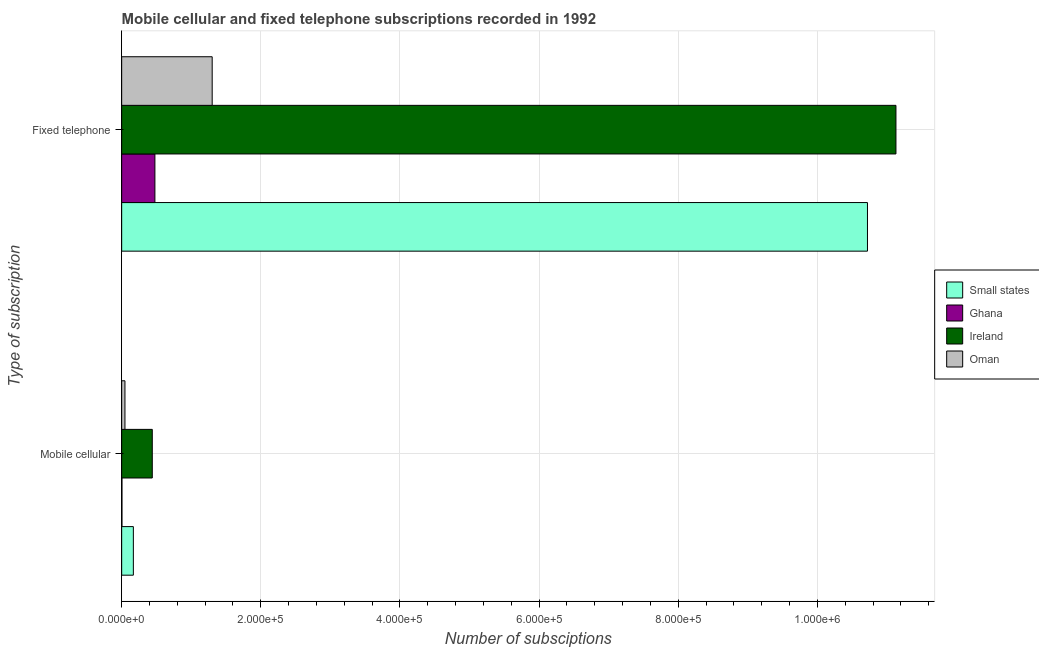Are the number of bars on each tick of the Y-axis equal?
Offer a terse response. Yes. What is the label of the 2nd group of bars from the top?
Your response must be concise. Mobile cellular. What is the number of mobile cellular subscriptions in Small states?
Make the answer very short. 1.68e+04. Across all countries, what is the maximum number of fixed telephone subscriptions?
Ensure brevity in your answer.  1.11e+06. Across all countries, what is the minimum number of mobile cellular subscriptions?
Your answer should be very brief. 400. In which country was the number of fixed telephone subscriptions maximum?
Keep it short and to the point. Ireland. In which country was the number of mobile cellular subscriptions minimum?
Make the answer very short. Ghana. What is the total number of fixed telephone subscriptions in the graph?
Provide a succinct answer. 2.36e+06. What is the difference between the number of fixed telephone subscriptions in Ireland and that in Ghana?
Make the answer very short. 1.07e+06. What is the difference between the number of mobile cellular subscriptions in Oman and the number of fixed telephone subscriptions in Small states?
Offer a terse response. -1.07e+06. What is the average number of mobile cellular subscriptions per country?
Provide a succinct answer. 1.65e+04. What is the difference between the number of mobile cellular subscriptions and number of fixed telephone subscriptions in Ireland?
Keep it short and to the point. -1.07e+06. What is the ratio of the number of fixed telephone subscriptions in Oman to that in Small states?
Your answer should be compact. 0.12. What does the 2nd bar from the top in Fixed telephone represents?
Your answer should be compact. Ireland. What does the 3rd bar from the bottom in Mobile cellular represents?
Ensure brevity in your answer.  Ireland. How many bars are there?
Provide a succinct answer. 8. How many countries are there in the graph?
Make the answer very short. 4. Are the values on the major ticks of X-axis written in scientific E-notation?
Ensure brevity in your answer.  Yes. Where does the legend appear in the graph?
Your answer should be compact. Center right. How many legend labels are there?
Your response must be concise. 4. How are the legend labels stacked?
Provide a succinct answer. Vertical. What is the title of the graph?
Ensure brevity in your answer.  Mobile cellular and fixed telephone subscriptions recorded in 1992. Does "Bahrain" appear as one of the legend labels in the graph?
Ensure brevity in your answer.  No. What is the label or title of the X-axis?
Keep it short and to the point. Number of subsciptions. What is the label or title of the Y-axis?
Ensure brevity in your answer.  Type of subscription. What is the Number of subsciptions in Small states in Mobile cellular?
Provide a succinct answer. 1.68e+04. What is the Number of subsciptions of Ghana in Mobile cellular?
Keep it short and to the point. 400. What is the Number of subsciptions of Ireland in Mobile cellular?
Provide a succinct answer. 4.40e+04. What is the Number of subsciptions in Oman in Mobile cellular?
Keep it short and to the point. 4721. What is the Number of subsciptions in Small states in Fixed telephone?
Offer a very short reply. 1.07e+06. What is the Number of subsciptions in Ghana in Fixed telephone?
Provide a short and direct response. 4.78e+04. What is the Number of subsciptions in Ireland in Fixed telephone?
Keep it short and to the point. 1.11e+06. What is the Number of subsciptions in Oman in Fixed telephone?
Your response must be concise. 1.30e+05. Across all Type of subscription, what is the maximum Number of subsciptions in Small states?
Your response must be concise. 1.07e+06. Across all Type of subscription, what is the maximum Number of subsciptions of Ghana?
Offer a terse response. 4.78e+04. Across all Type of subscription, what is the maximum Number of subsciptions in Ireland?
Offer a very short reply. 1.11e+06. Across all Type of subscription, what is the maximum Number of subsciptions of Oman?
Your answer should be very brief. 1.30e+05. Across all Type of subscription, what is the minimum Number of subsciptions of Small states?
Offer a terse response. 1.68e+04. Across all Type of subscription, what is the minimum Number of subsciptions in Ireland?
Your answer should be compact. 4.40e+04. Across all Type of subscription, what is the minimum Number of subsciptions of Oman?
Give a very brief answer. 4721. What is the total Number of subsciptions in Small states in the graph?
Your answer should be compact. 1.09e+06. What is the total Number of subsciptions of Ghana in the graph?
Offer a terse response. 4.82e+04. What is the total Number of subsciptions in Ireland in the graph?
Offer a terse response. 1.16e+06. What is the total Number of subsciptions of Oman in the graph?
Your answer should be compact. 1.35e+05. What is the difference between the Number of subsciptions of Small states in Mobile cellular and that in Fixed telephone?
Make the answer very short. -1.06e+06. What is the difference between the Number of subsciptions in Ghana in Mobile cellular and that in Fixed telephone?
Your answer should be very brief. -4.74e+04. What is the difference between the Number of subsciptions of Ireland in Mobile cellular and that in Fixed telephone?
Offer a very short reply. -1.07e+06. What is the difference between the Number of subsciptions in Oman in Mobile cellular and that in Fixed telephone?
Make the answer very short. -1.25e+05. What is the difference between the Number of subsciptions in Small states in Mobile cellular and the Number of subsciptions in Ghana in Fixed telephone?
Provide a succinct answer. -3.10e+04. What is the difference between the Number of subsciptions in Small states in Mobile cellular and the Number of subsciptions in Ireland in Fixed telephone?
Your answer should be compact. -1.10e+06. What is the difference between the Number of subsciptions of Small states in Mobile cellular and the Number of subsciptions of Oman in Fixed telephone?
Your response must be concise. -1.13e+05. What is the difference between the Number of subsciptions of Ghana in Mobile cellular and the Number of subsciptions of Ireland in Fixed telephone?
Make the answer very short. -1.11e+06. What is the difference between the Number of subsciptions of Ghana in Mobile cellular and the Number of subsciptions of Oman in Fixed telephone?
Provide a short and direct response. -1.30e+05. What is the difference between the Number of subsciptions in Ireland in Mobile cellular and the Number of subsciptions in Oman in Fixed telephone?
Provide a short and direct response. -8.61e+04. What is the average Number of subsciptions of Small states per Type of subscription?
Give a very brief answer. 5.44e+05. What is the average Number of subsciptions of Ghana per Type of subscription?
Offer a very short reply. 2.41e+04. What is the average Number of subsciptions in Ireland per Type of subscription?
Ensure brevity in your answer.  5.78e+05. What is the average Number of subsciptions of Oman per Type of subscription?
Your response must be concise. 6.74e+04. What is the difference between the Number of subsciptions in Small states and Number of subsciptions in Ghana in Mobile cellular?
Provide a short and direct response. 1.64e+04. What is the difference between the Number of subsciptions of Small states and Number of subsciptions of Ireland in Mobile cellular?
Your answer should be compact. -2.72e+04. What is the difference between the Number of subsciptions in Small states and Number of subsciptions in Oman in Mobile cellular?
Offer a terse response. 1.21e+04. What is the difference between the Number of subsciptions in Ghana and Number of subsciptions in Ireland in Mobile cellular?
Provide a short and direct response. -4.36e+04. What is the difference between the Number of subsciptions of Ghana and Number of subsciptions of Oman in Mobile cellular?
Provide a short and direct response. -4321. What is the difference between the Number of subsciptions in Ireland and Number of subsciptions in Oman in Mobile cellular?
Keep it short and to the point. 3.93e+04. What is the difference between the Number of subsciptions in Small states and Number of subsciptions in Ghana in Fixed telephone?
Provide a short and direct response. 1.02e+06. What is the difference between the Number of subsciptions in Small states and Number of subsciptions in Ireland in Fixed telephone?
Offer a terse response. -4.09e+04. What is the difference between the Number of subsciptions of Small states and Number of subsciptions of Oman in Fixed telephone?
Make the answer very short. 9.42e+05. What is the difference between the Number of subsciptions of Ghana and Number of subsciptions of Ireland in Fixed telephone?
Ensure brevity in your answer.  -1.07e+06. What is the difference between the Number of subsciptions in Ghana and Number of subsciptions in Oman in Fixed telephone?
Offer a very short reply. -8.23e+04. What is the difference between the Number of subsciptions of Ireland and Number of subsciptions of Oman in Fixed telephone?
Keep it short and to the point. 9.83e+05. What is the ratio of the Number of subsciptions of Small states in Mobile cellular to that in Fixed telephone?
Make the answer very short. 0.02. What is the ratio of the Number of subsciptions in Ghana in Mobile cellular to that in Fixed telephone?
Your response must be concise. 0.01. What is the ratio of the Number of subsciptions in Ireland in Mobile cellular to that in Fixed telephone?
Your answer should be compact. 0.04. What is the ratio of the Number of subsciptions of Oman in Mobile cellular to that in Fixed telephone?
Provide a succinct answer. 0.04. What is the difference between the highest and the second highest Number of subsciptions in Small states?
Provide a short and direct response. 1.06e+06. What is the difference between the highest and the second highest Number of subsciptions of Ghana?
Offer a very short reply. 4.74e+04. What is the difference between the highest and the second highest Number of subsciptions in Ireland?
Make the answer very short. 1.07e+06. What is the difference between the highest and the second highest Number of subsciptions in Oman?
Offer a very short reply. 1.25e+05. What is the difference between the highest and the lowest Number of subsciptions of Small states?
Ensure brevity in your answer.  1.06e+06. What is the difference between the highest and the lowest Number of subsciptions in Ghana?
Your answer should be compact. 4.74e+04. What is the difference between the highest and the lowest Number of subsciptions of Ireland?
Ensure brevity in your answer.  1.07e+06. What is the difference between the highest and the lowest Number of subsciptions of Oman?
Your answer should be compact. 1.25e+05. 